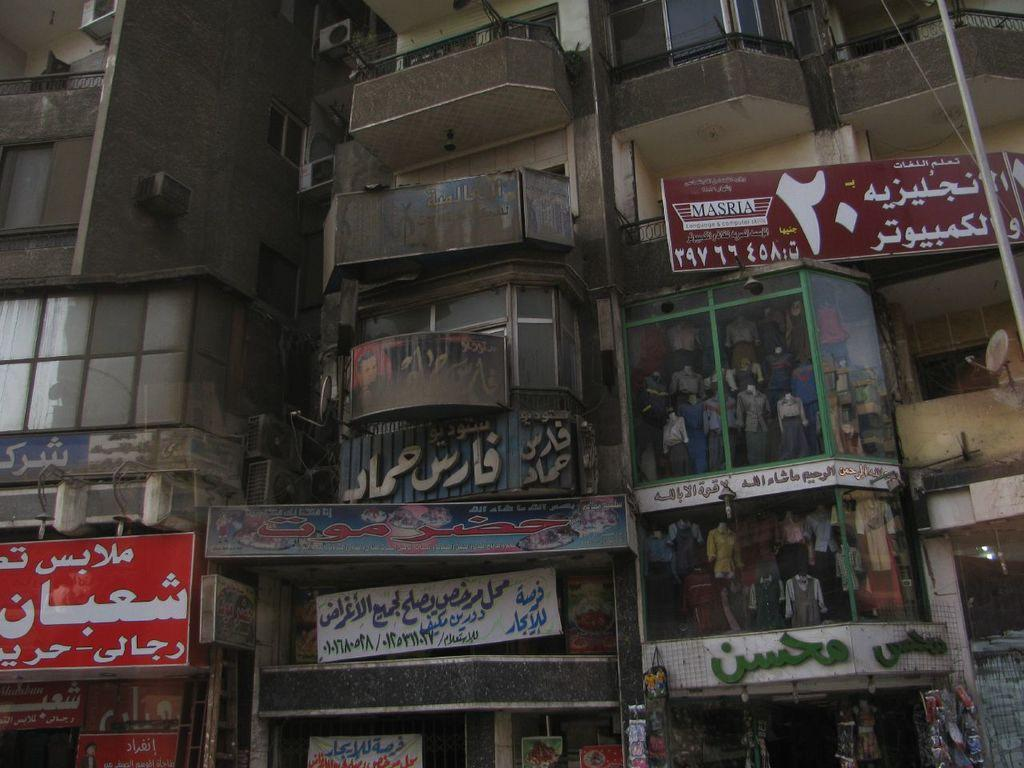What type of structures can be seen in the image? There are buildings in the image. What feature do the buildings have? The buildings have windows. What additional elements are present in the image? There are banners and mannequins in the image. What type of hand can be seen holding a pancake in the image? There is no hand or pancake present in the image. How many chickens are visible in the image? There are no chickens visible in the image. 